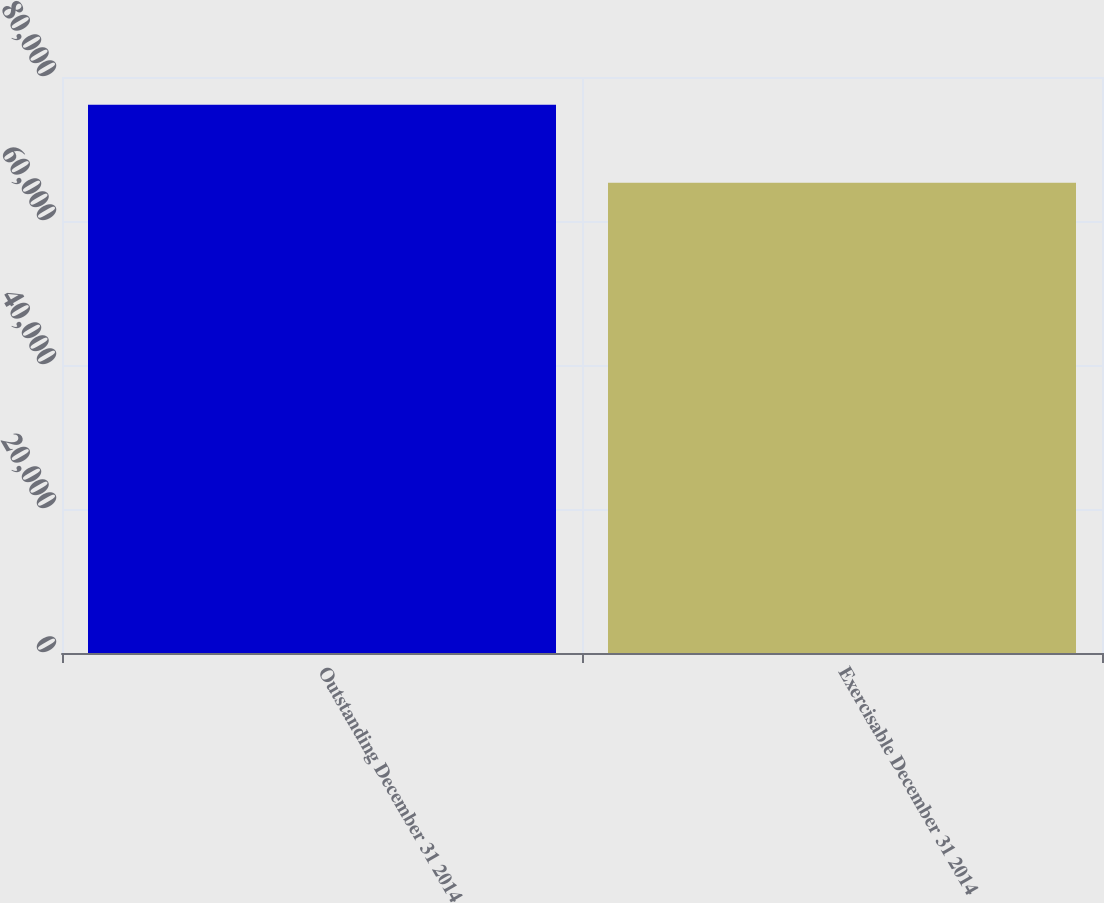<chart> <loc_0><loc_0><loc_500><loc_500><bar_chart><fcel>Outstanding December 31 2014<fcel>Exercisable December 31 2014<nl><fcel>76135<fcel>65324<nl></chart> 